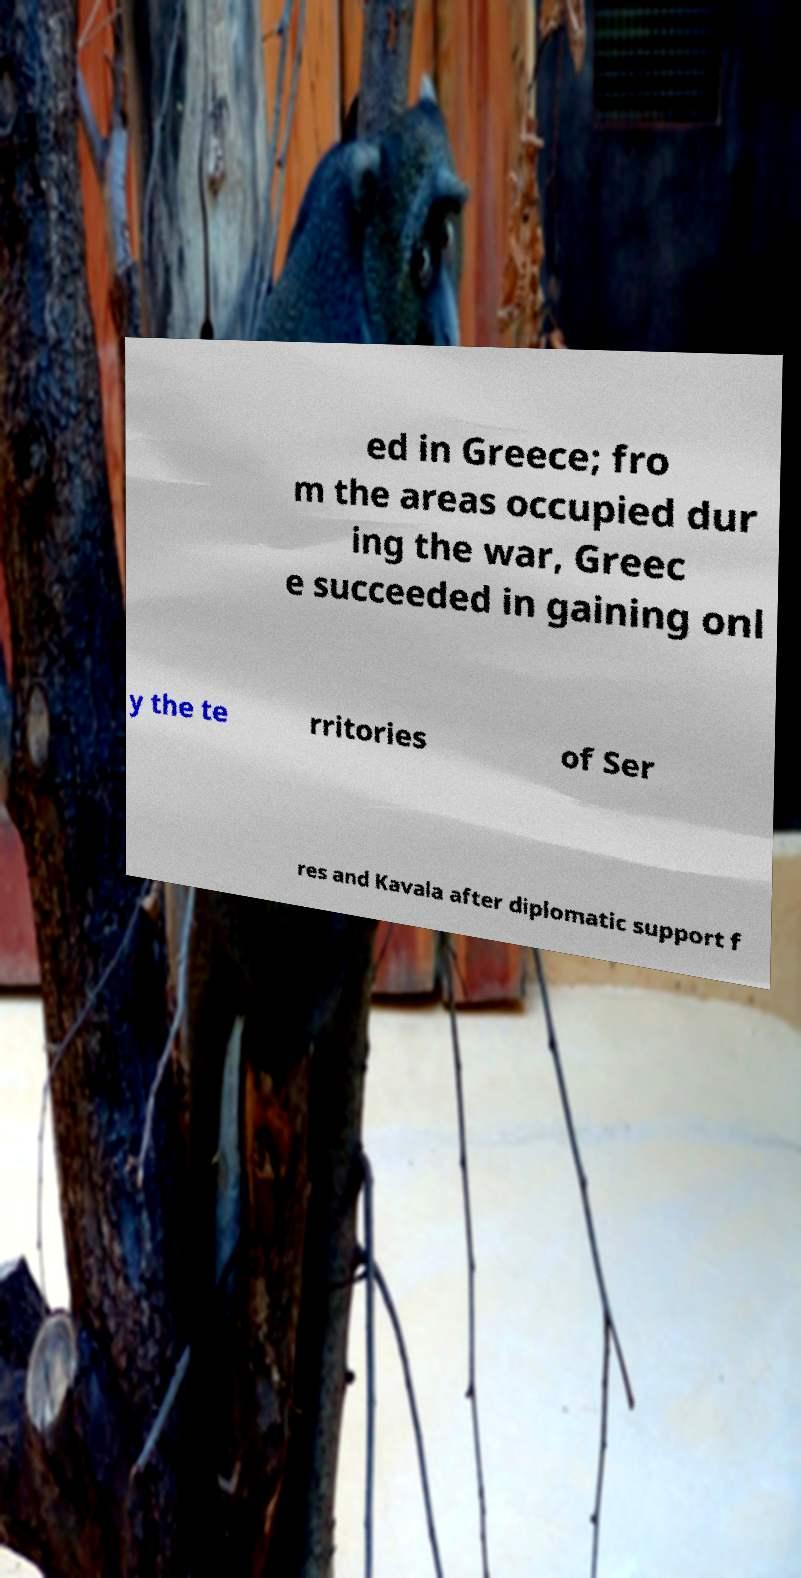Could you extract and type out the text from this image? ed in Greece; fro m the areas occupied dur ing the war, Greec e succeeded in gaining onl y the te rritories of Ser res and Kavala after diplomatic support f 